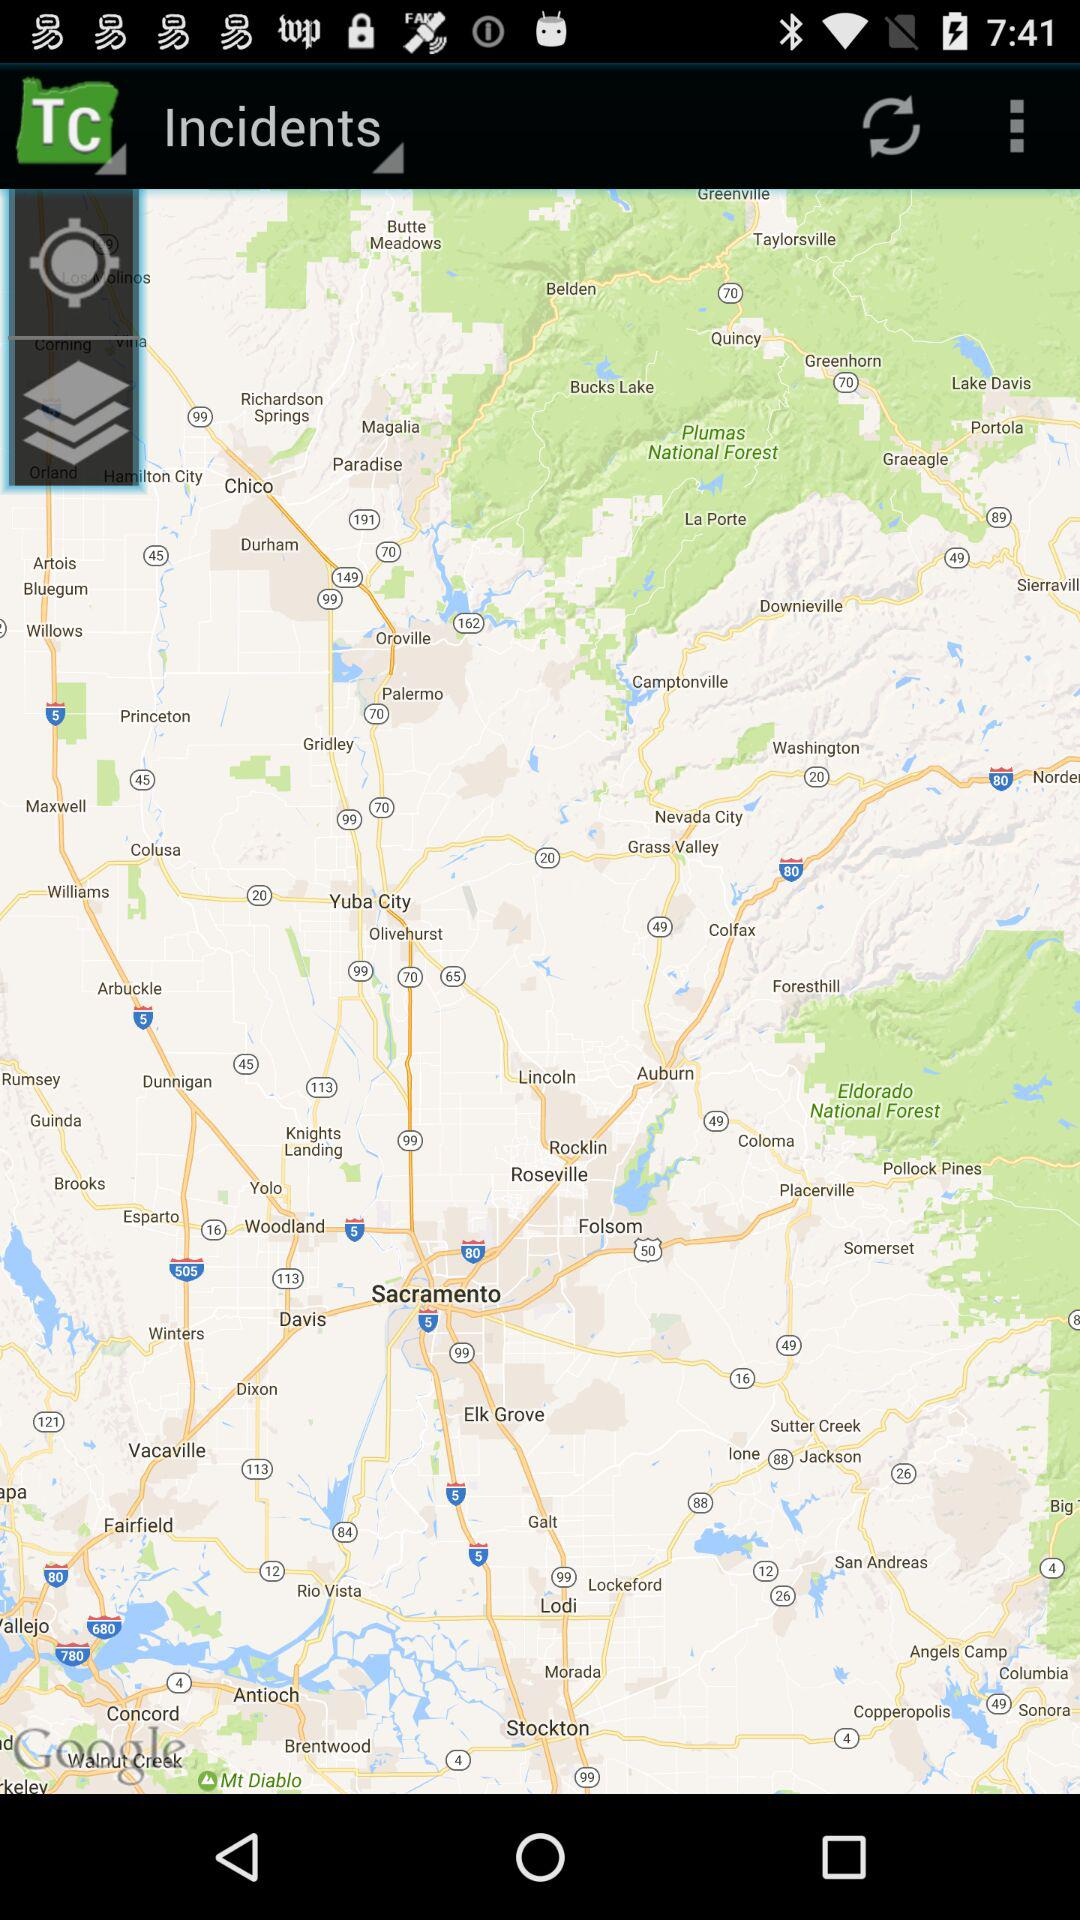What is the application name?
When the provided information is insufficient, respond with <no answer>. <no answer> 